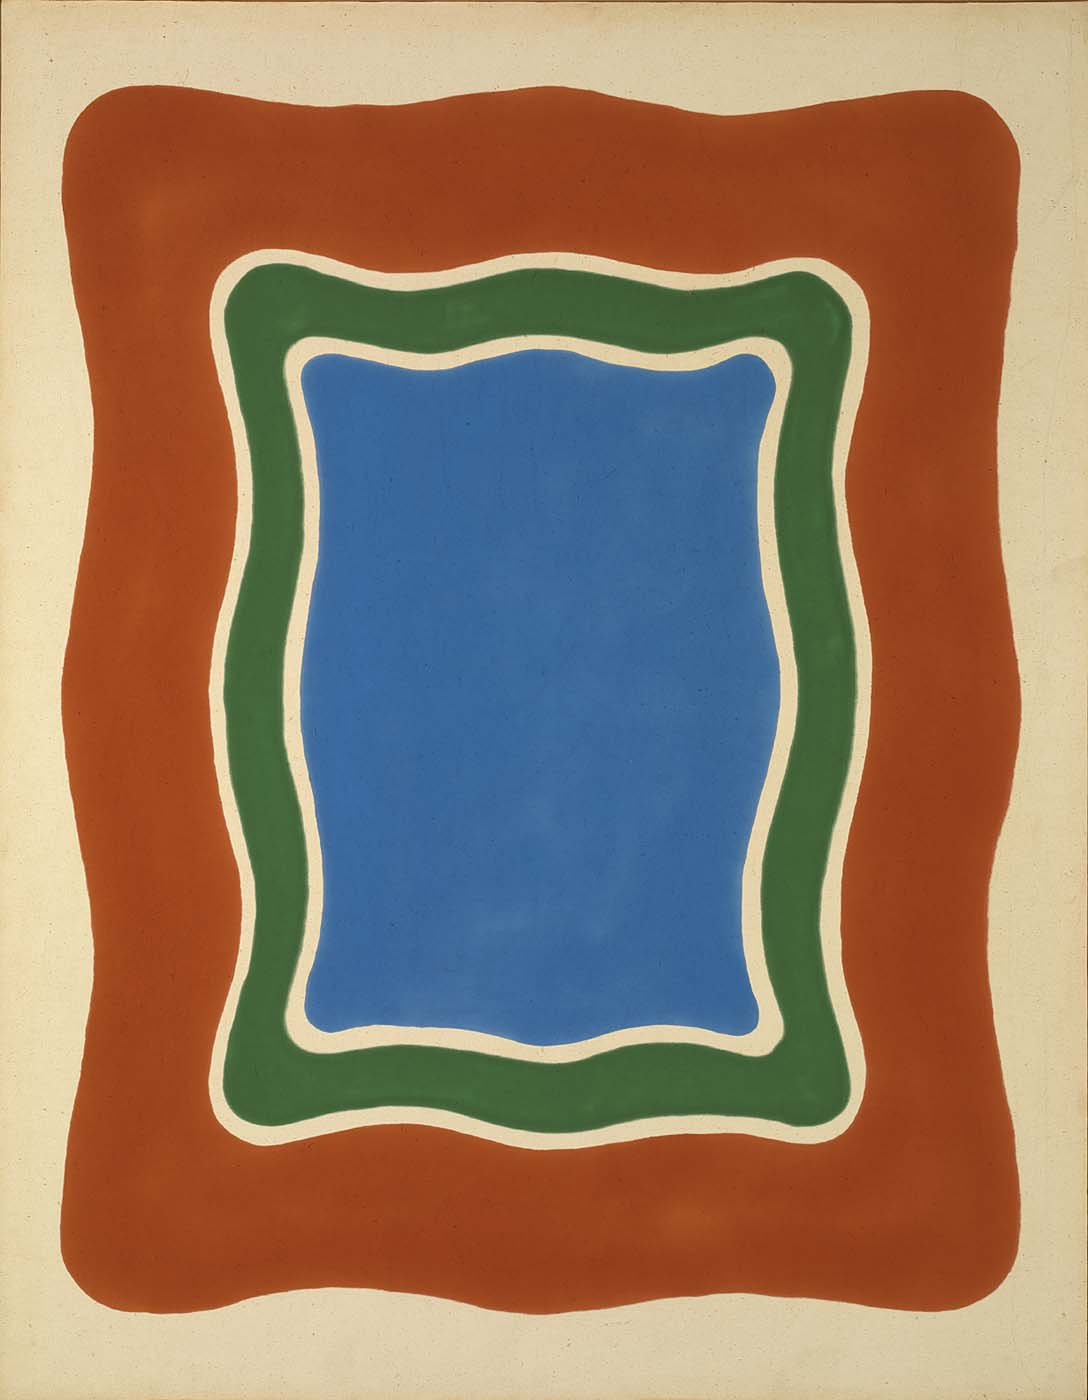What emotion does the use of blue in the center of the image evoke? The vibrant blue at the center of the image often evokes feelings of calmness and serenity, reminiscent of the sky or a deep ocean. This calming effect can make the viewer feel more connected to the artwork, invoking a meditative state that allows for deeper engagement with the abstract forms. 